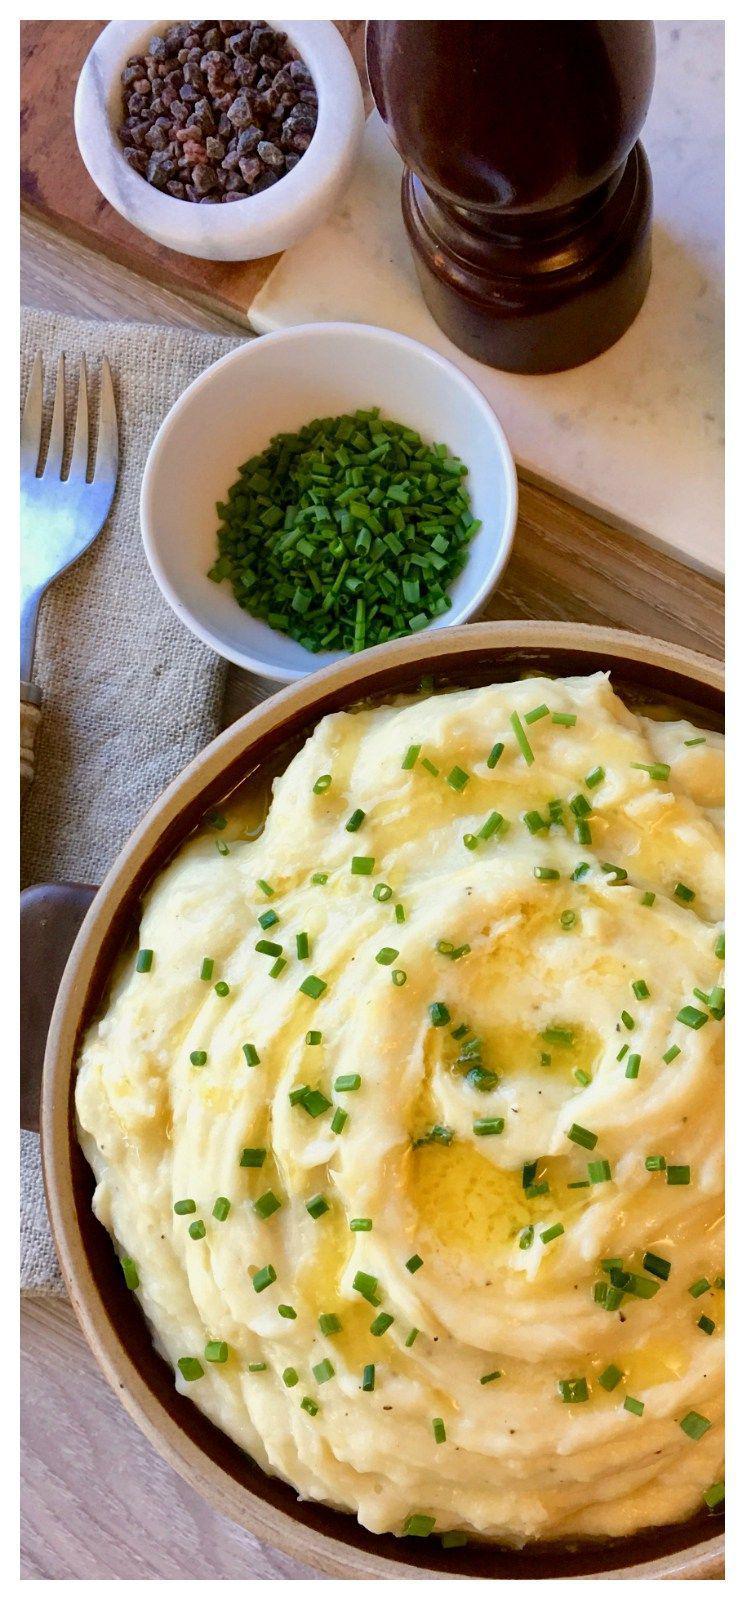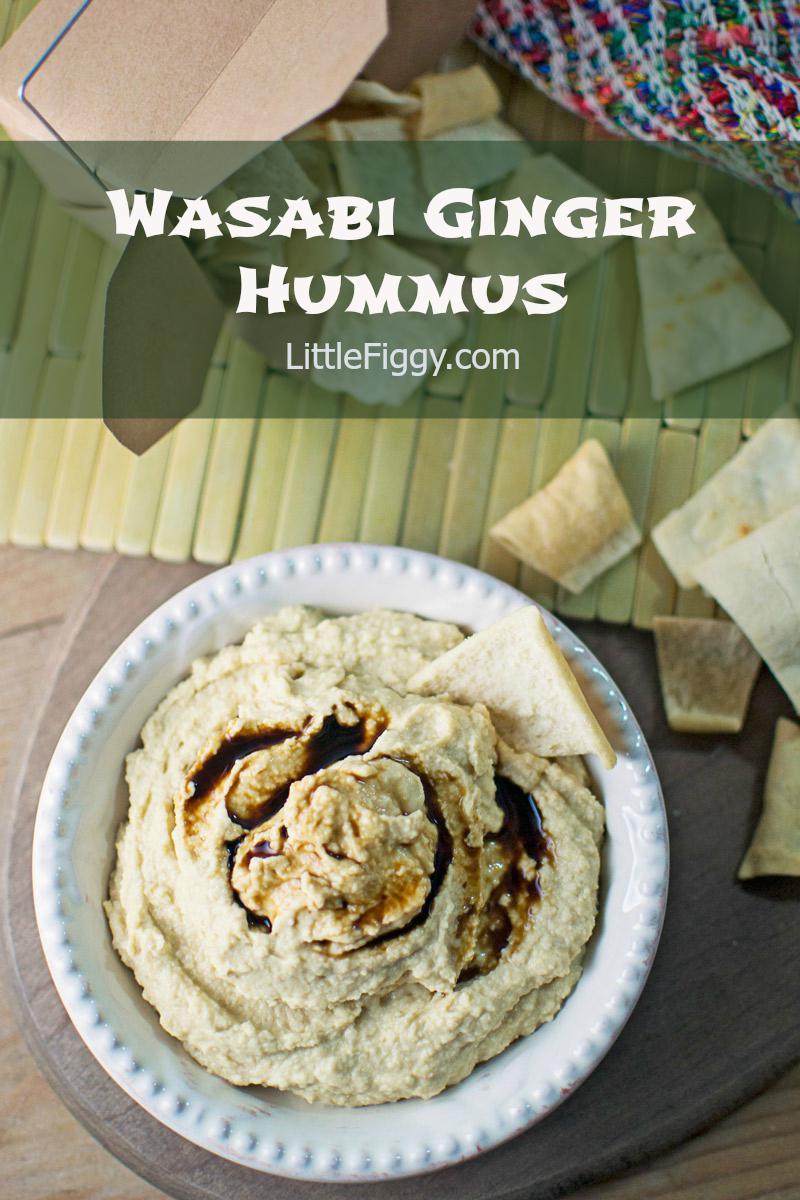The first image is the image on the left, the second image is the image on the right. For the images shown, is this caption "Left image shows food served in a white, non-square dish with textured design." true? Answer yes or no. No. The first image is the image on the left, the second image is the image on the right. For the images shown, is this caption "Green garnishes are sprinkled over both dishes." true? Answer yes or no. No. 